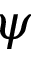Convert formula to latex. <formula><loc_0><loc_0><loc_500><loc_500>\psi</formula> 